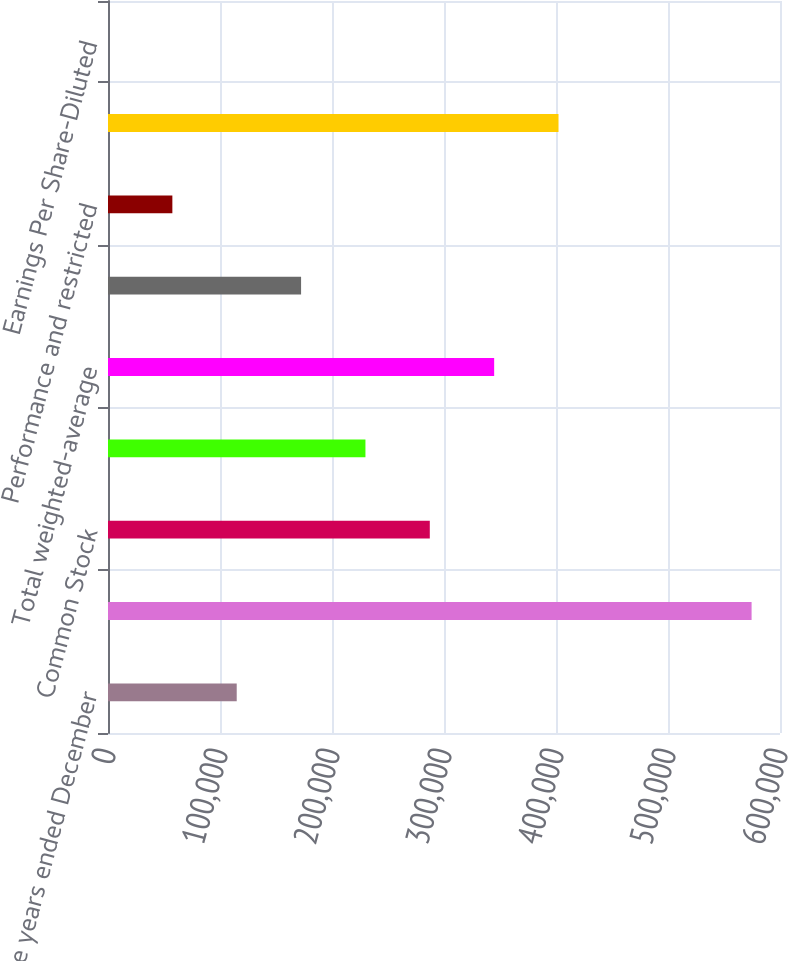<chart> <loc_0><loc_0><loc_500><loc_500><bar_chart><fcel>For the years ended December<fcel>Net income<fcel>Common Stock<fcel>Class B Stock<fcel>Total weighted-average<fcel>Employee stock options<fcel>Performance and restricted<fcel>Weighted-average<fcel>Earnings Per Share-Diluted<nl><fcel>114929<fcel>574637<fcel>287320<fcel>229856<fcel>344783<fcel>172393<fcel>57465.7<fcel>402247<fcel>2.24<nl></chart> 